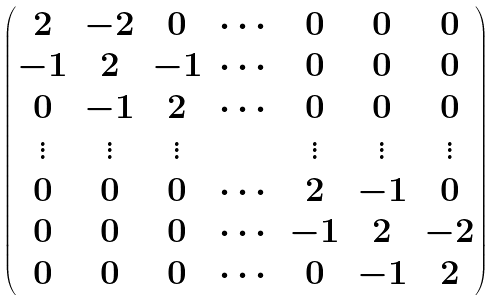Convert formula to latex. <formula><loc_0><loc_0><loc_500><loc_500>\begin{pmatrix} 2 & - 2 & 0 & \cdots & 0 & 0 & 0 \\ - 1 & 2 & - 1 & \cdots & 0 & 0 & 0 \\ 0 & - 1 & 2 & \cdots & 0 & 0 & 0 \\ \vdots & \vdots & \vdots & & \vdots & \vdots & \vdots \\ 0 & 0 & 0 & \cdots & 2 & - 1 & 0 \\ 0 & 0 & 0 & \cdots & - 1 & 2 & - 2 \\ 0 & 0 & 0 & \cdots & 0 & - 1 & 2 \end{pmatrix}</formula> 